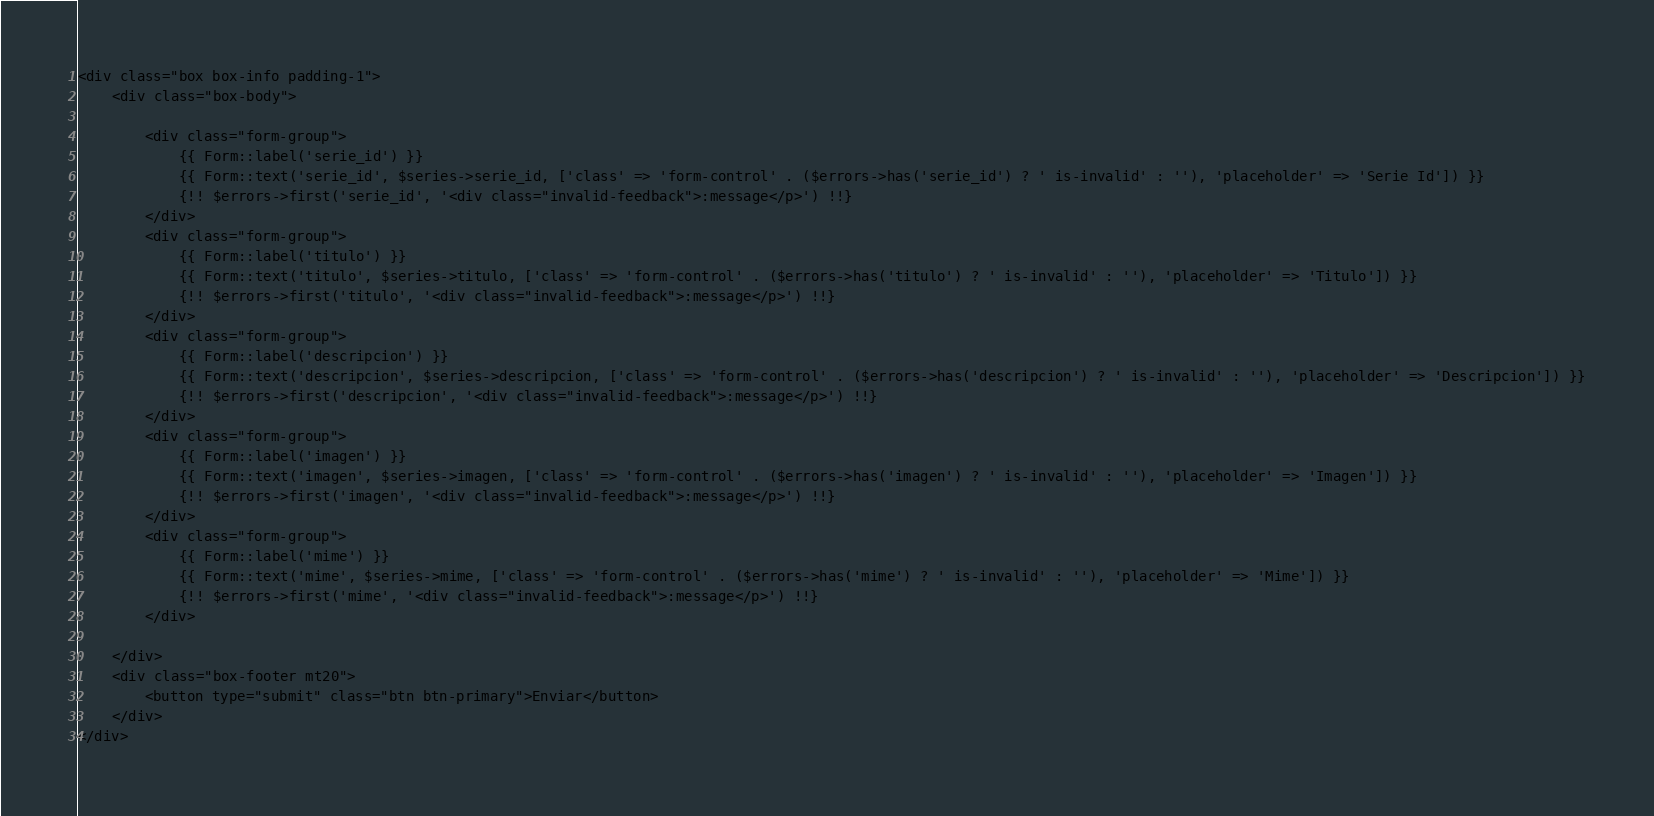<code> <loc_0><loc_0><loc_500><loc_500><_PHP_><div class="box box-info padding-1">
    <div class="box-body">

        <div class="form-group">
            {{ Form::label('serie_id') }}
            {{ Form::text('serie_id', $series->serie_id, ['class' => 'form-control' . ($errors->has('serie_id') ? ' is-invalid' : ''), 'placeholder' => 'Serie Id']) }}
            {!! $errors->first('serie_id', '<div class="invalid-feedback">:message</p>') !!}
        </div>
        <div class="form-group">
            {{ Form::label('titulo') }}
            {{ Form::text('titulo', $series->titulo, ['class' => 'form-control' . ($errors->has('titulo') ? ' is-invalid' : ''), 'placeholder' => 'Titulo']) }}
            {!! $errors->first('titulo', '<div class="invalid-feedback">:message</p>') !!}
        </div>
        <div class="form-group">
            {{ Form::label('descripcion') }}
            {{ Form::text('descripcion', $series->descripcion, ['class' => 'form-control' . ($errors->has('descripcion') ? ' is-invalid' : ''), 'placeholder' => 'Descripcion']) }}
            {!! $errors->first('descripcion', '<div class="invalid-feedback">:message</p>') !!}
        </div>
        <div class="form-group">
            {{ Form::label('imagen') }}
            {{ Form::text('imagen', $series->imagen, ['class' => 'form-control' . ($errors->has('imagen') ? ' is-invalid' : ''), 'placeholder' => 'Imagen']) }}
            {!! $errors->first('imagen', '<div class="invalid-feedback">:message</p>') !!}
        </div>
        <div class="form-group">
            {{ Form::label('mime') }}
            {{ Form::text('mime', $series->mime, ['class' => 'form-control' . ($errors->has('mime') ? ' is-invalid' : ''), 'placeholder' => 'Mime']) }}
            {!! $errors->first('mime', '<div class="invalid-feedback">:message</p>') !!}
        </div>

    </div>
    <div class="box-footer mt20">
        <button type="submit" class="btn btn-primary">Enviar</button>
    </div>
</div>
</code> 